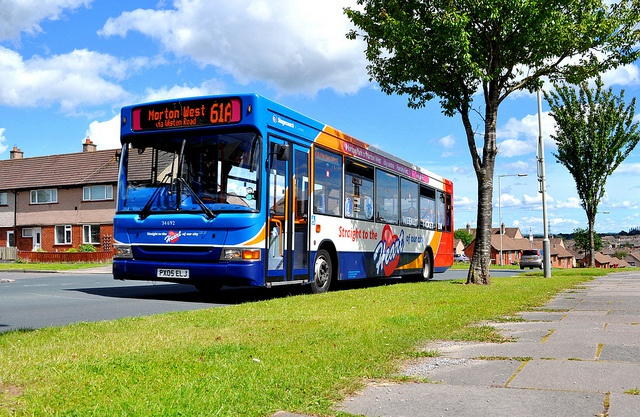Describe the objects in this image and their specific colors. I can see bus in darkgray, black, navy, and white tones, car in darkgray, black, gray, and lightgray tones, and car in darkgray, gray, and black tones in this image. 